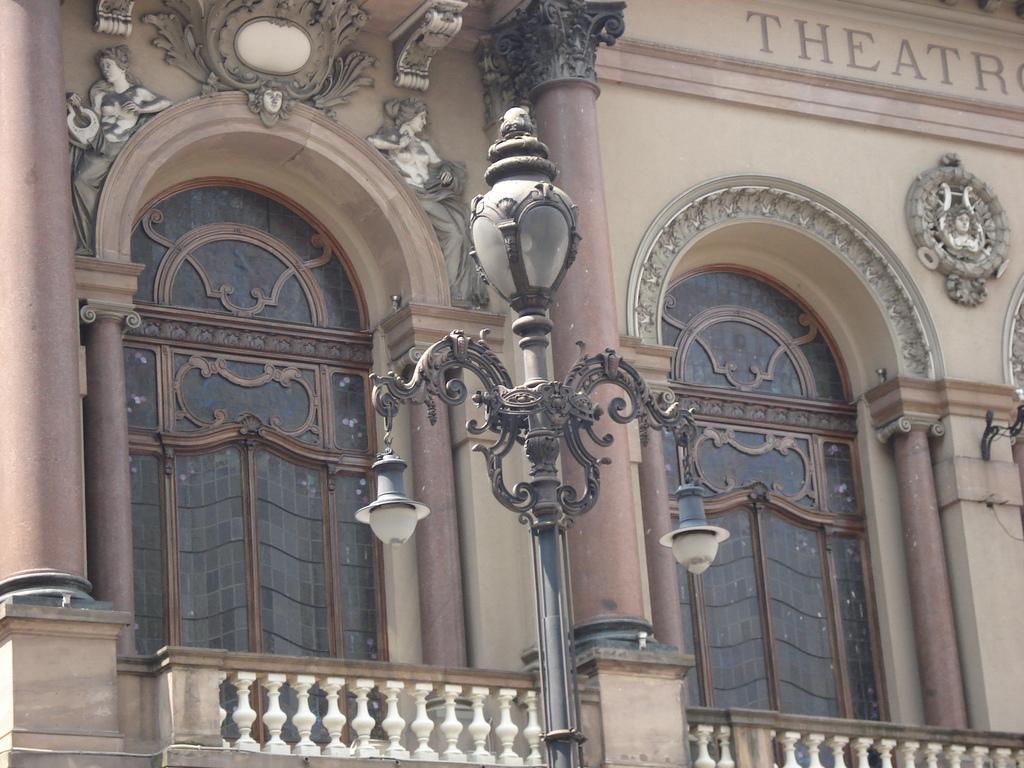How would you summarize this image in a sentence or two? In this image we can see a pole, lights, railings, pillars, arches, designed wall, and something is written on the wall. 